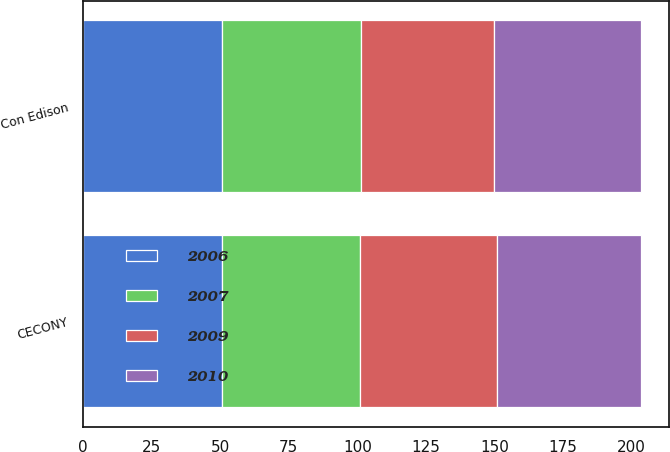Convert chart. <chart><loc_0><loc_0><loc_500><loc_500><stacked_bar_chart><ecel><fcel>Con Edison<fcel>CECONY<nl><fcel>2009<fcel>48.5<fcel>50<nl><fcel>2010<fcel>53.7<fcel>52.3<nl><fcel>2006<fcel>50.7<fcel>50.8<nl><fcel>2007<fcel>50.5<fcel>50.3<nl></chart> 